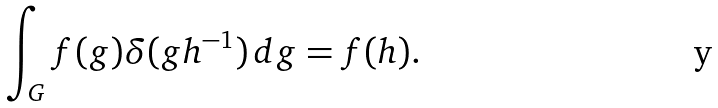<formula> <loc_0><loc_0><loc_500><loc_500>\int _ { G } f ( g ) \delta ( g h ^ { - 1 } ) \, d g = f ( h ) .</formula> 